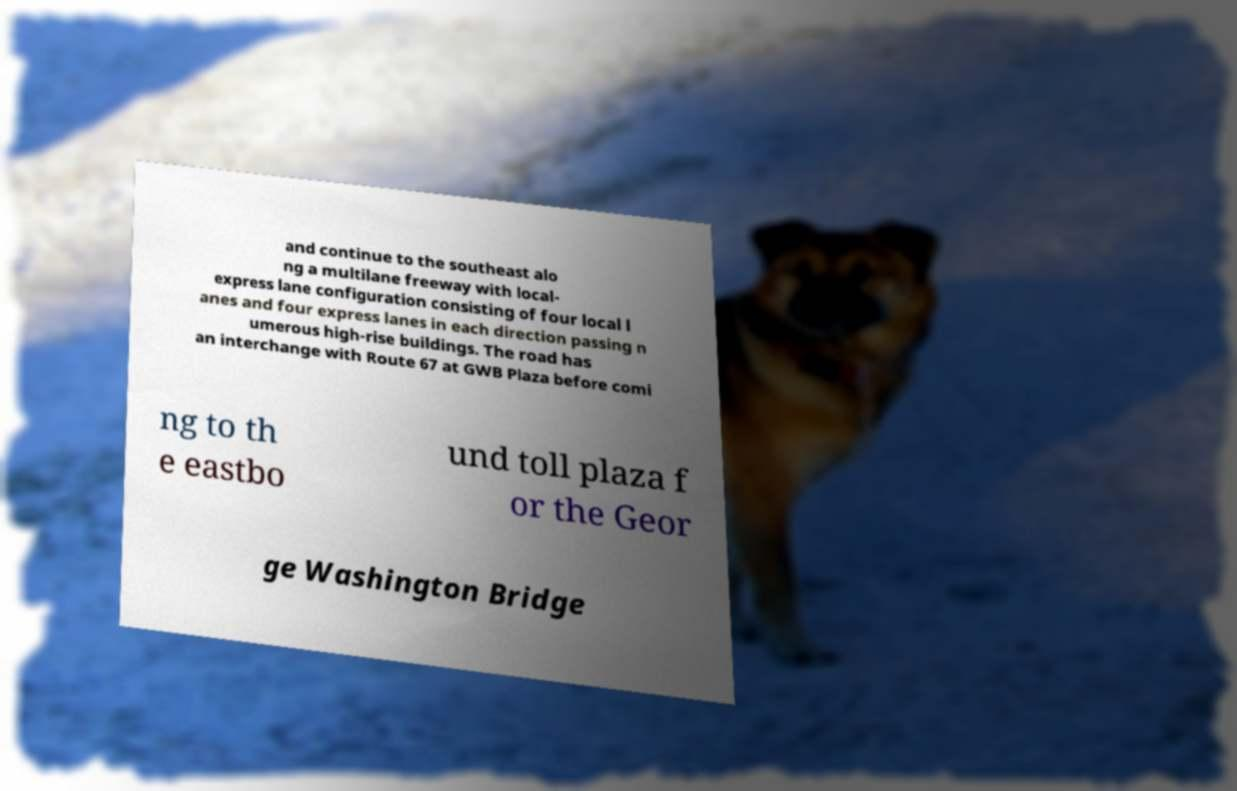Could you assist in decoding the text presented in this image and type it out clearly? and continue to the southeast alo ng a multilane freeway with local- express lane configuration consisting of four local l anes and four express lanes in each direction passing n umerous high-rise buildings. The road has an interchange with Route 67 at GWB Plaza before comi ng to th e eastbo und toll plaza f or the Geor ge Washington Bridge 